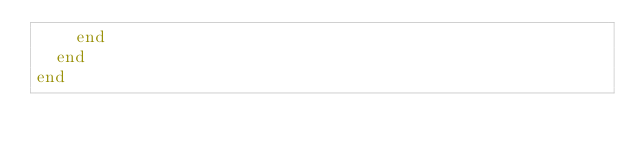<code> <loc_0><loc_0><loc_500><loc_500><_Ruby_>    end
  end
end
</code> 